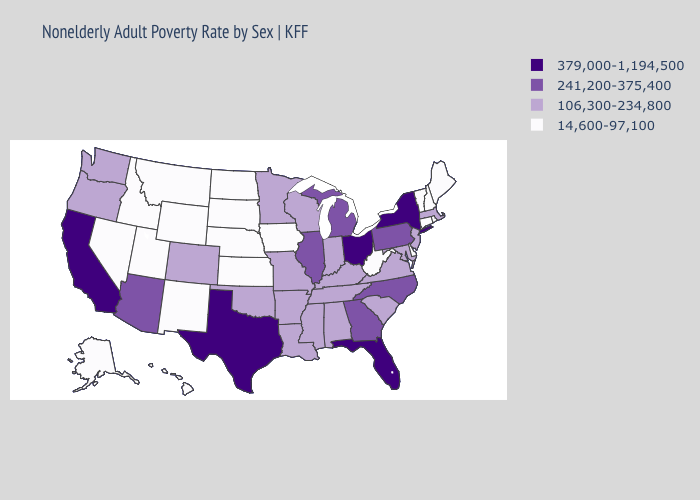Name the states that have a value in the range 379,000-1,194,500?
Answer briefly. California, Florida, New York, Ohio, Texas. What is the highest value in the MidWest ?
Quick response, please. 379,000-1,194,500. What is the value of Washington?
Concise answer only. 106,300-234,800. What is the lowest value in the USA?
Give a very brief answer. 14,600-97,100. Among the states that border New Mexico , does Utah have the lowest value?
Concise answer only. Yes. Is the legend a continuous bar?
Keep it brief. No. Does Florida have a higher value than Massachusetts?
Write a very short answer. Yes. Name the states that have a value in the range 241,200-375,400?
Give a very brief answer. Arizona, Georgia, Illinois, Michigan, North Carolina, Pennsylvania. Among the states that border Massachusetts , does New York have the lowest value?
Concise answer only. No. Does Wisconsin have the lowest value in the MidWest?
Give a very brief answer. No. How many symbols are there in the legend?
Keep it brief. 4. Name the states that have a value in the range 106,300-234,800?
Write a very short answer. Alabama, Arkansas, Colorado, Indiana, Kentucky, Louisiana, Maryland, Massachusetts, Minnesota, Mississippi, Missouri, New Jersey, Oklahoma, Oregon, South Carolina, Tennessee, Virginia, Washington, Wisconsin. Among the states that border South Dakota , does North Dakota have the lowest value?
Concise answer only. Yes. Does Louisiana have a higher value than Mississippi?
Answer briefly. No. 